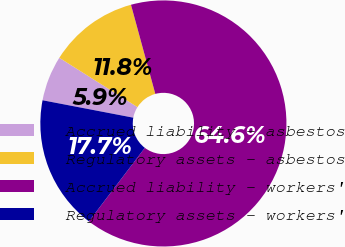Convert chart. <chart><loc_0><loc_0><loc_500><loc_500><pie_chart><fcel>Accrued liability - asbestos<fcel>Regulatory assets - asbestos<fcel>Accrued liability - workers'<fcel>Regulatory assets - workers'<nl><fcel>5.94%<fcel>11.8%<fcel>64.59%<fcel>17.67%<nl></chart> 